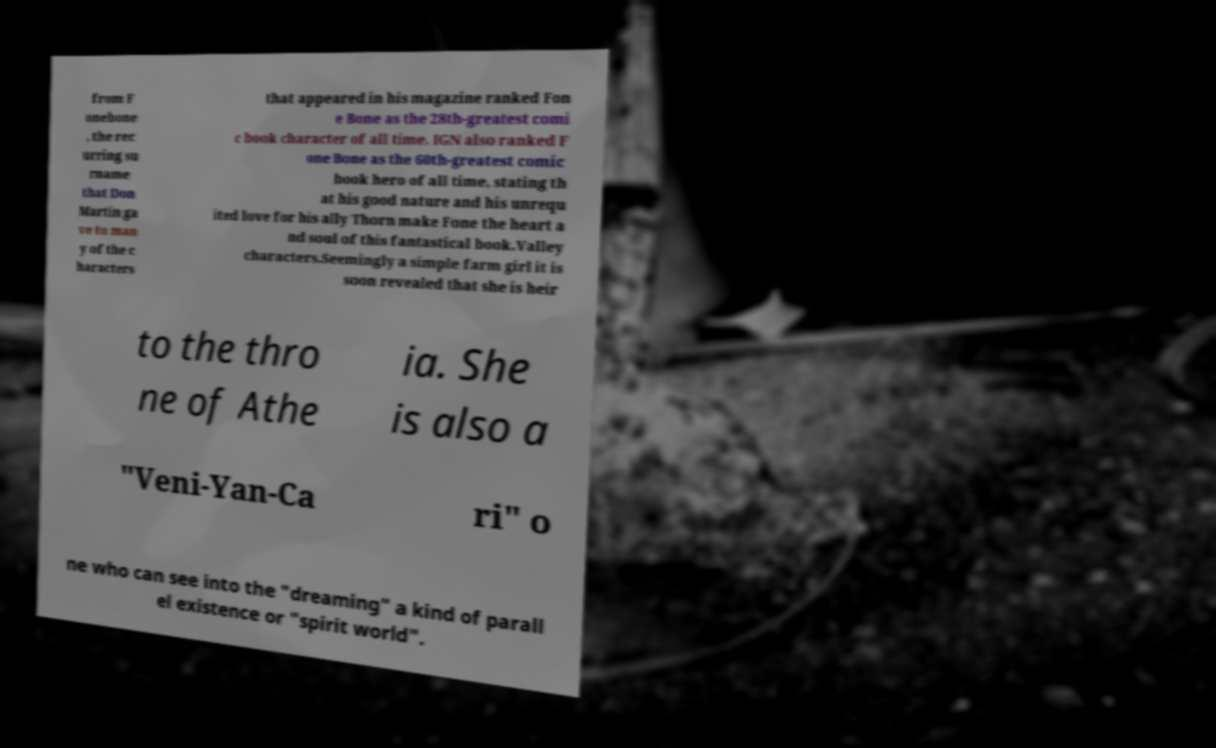Can you accurately transcribe the text from the provided image for me? from F onebone , the rec urring su rname that Don Martin ga ve to man y of the c haracters that appeared in his magazine ranked Fon e Bone as the 28th-greatest comi c book character of all time. IGN also ranked F one Bone as the 60th-greatest comic book hero of all time, stating th at his good nature and his unrequ ited love for his ally Thorn make Fone the heart a nd soul of this fantastical book.Valley characters.Seemingly a simple farm girl it is soon revealed that she is heir to the thro ne of Athe ia. She is also a "Veni-Yan-Ca ri" o ne who can see into the "dreaming" a kind of parall el existence or "spirit world". 